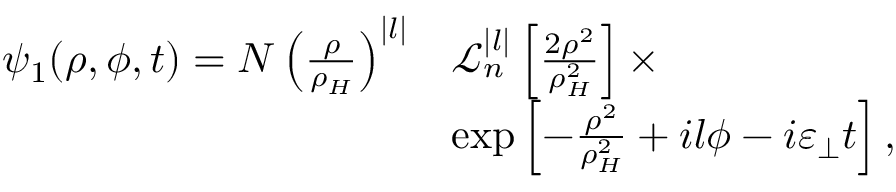<formula> <loc_0><loc_0><loc_500><loc_500>\begin{array} { r l } { \psi _ { 1 } ( \rho , \phi , t ) = N \left ( \frac { \rho } { \rho _ { H } } \right ) ^ { | l | } } & { \mathcal { L } _ { n } ^ { | l | } \left [ \frac { 2 \rho ^ { 2 } } { \rho _ { H } ^ { 2 } } \right ] \times } \\ & { \exp \left [ - \frac { \rho ^ { 2 } } { \rho _ { H } ^ { 2 } } + i l \phi - i \varepsilon _ { \perp } t \right ] , } \end{array}</formula> 